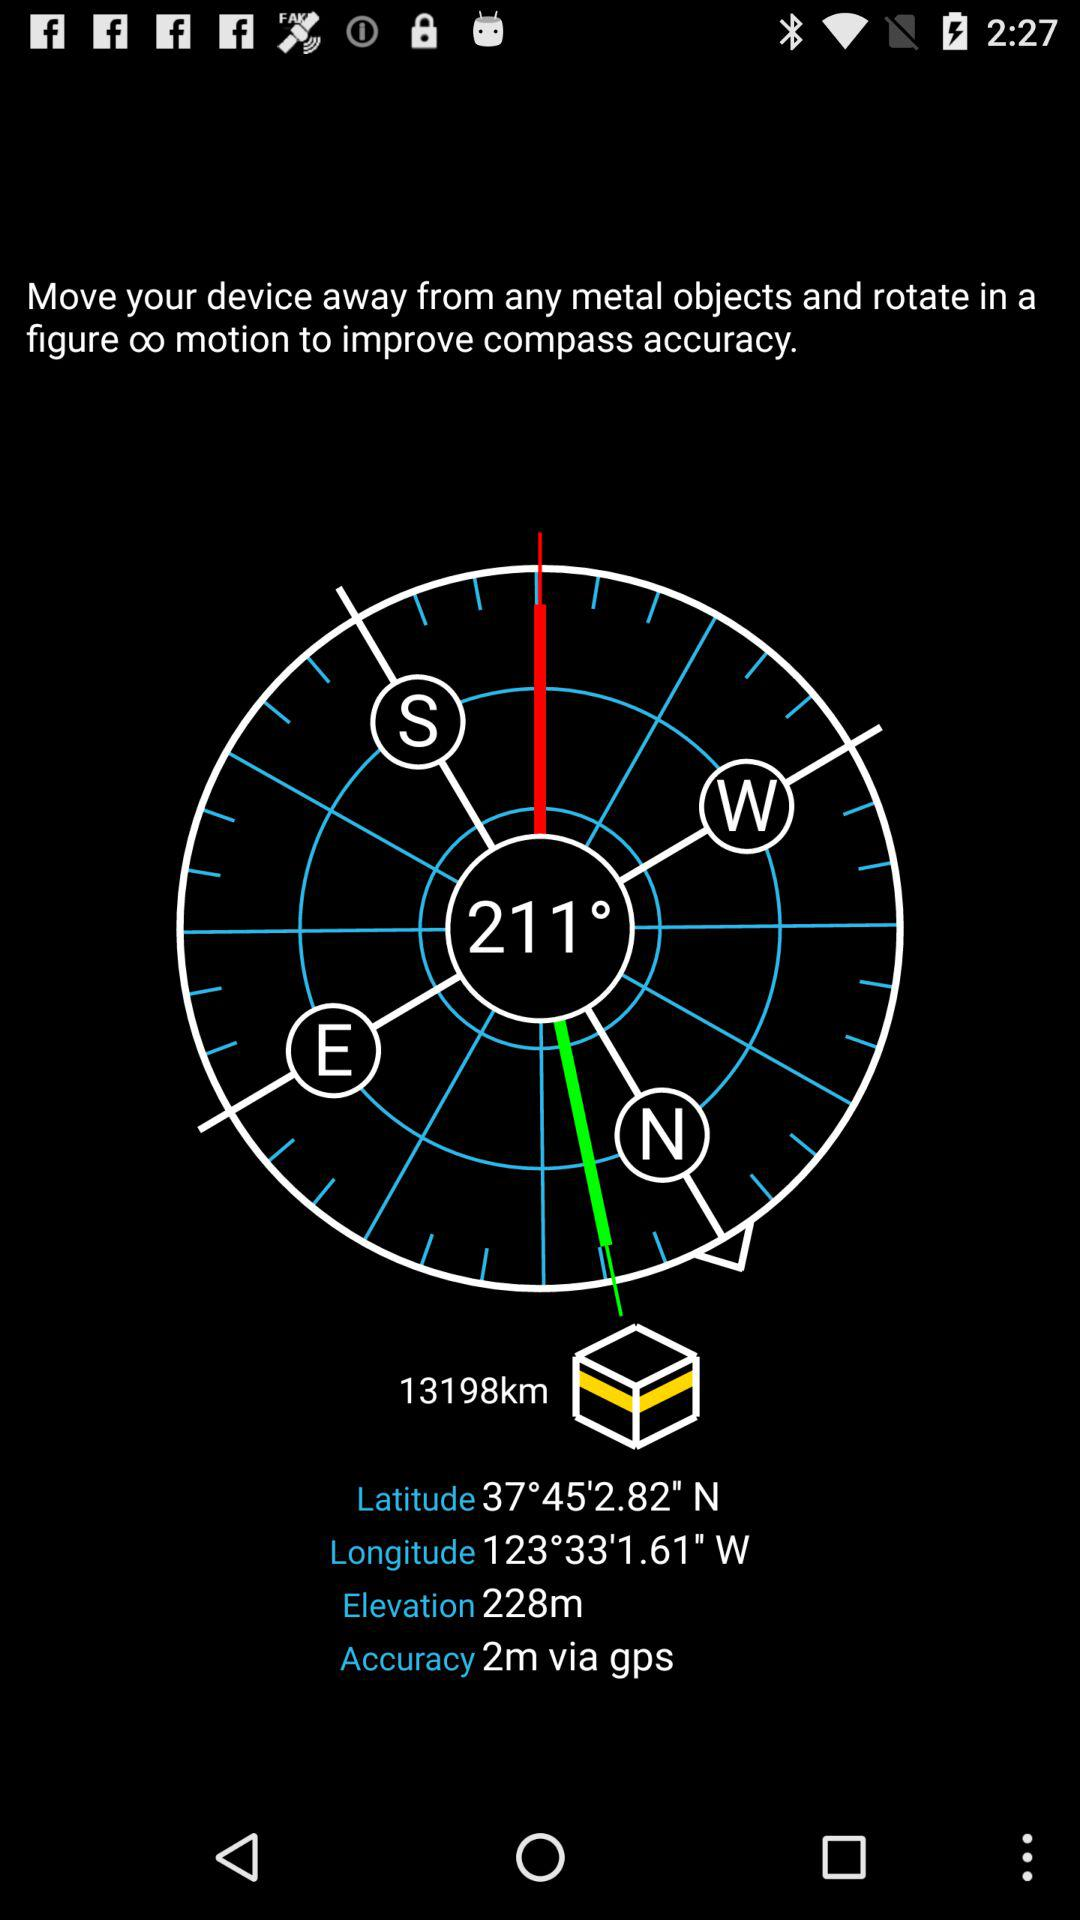What is the accuracy? The accuracy is 2 m via GPS. 